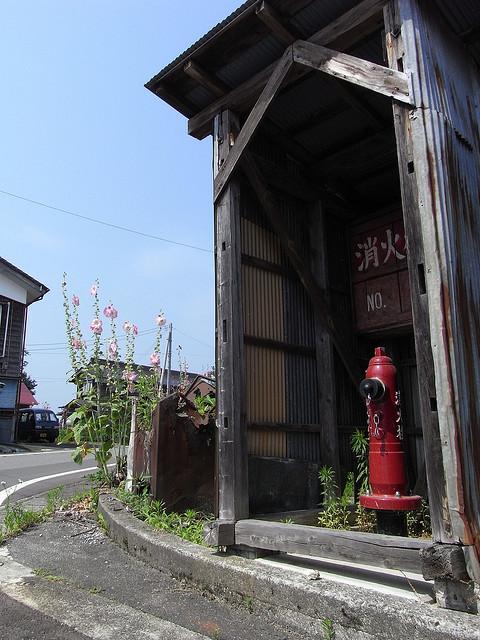What color are the flowers in the background?
Quick response, please. Pink. What sort of writing is on the wall behind the fire hydrant?
Write a very short answer. Chinese. Is this a Chinese village?
Concise answer only. Yes. 